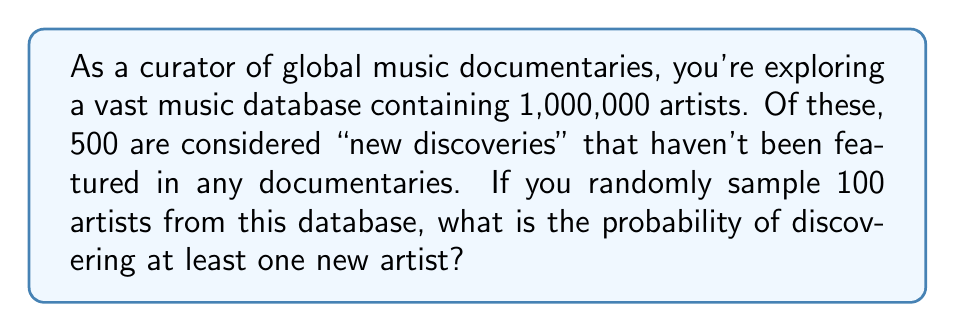Provide a solution to this math problem. Let's approach this step-by-step:

1) First, we need to calculate the probability of not selecting a new artist in a single draw:

   $P(\text{not new}) = \frac{1,000,000 - 500}{1,000,000} = 0.9995$

2) Now, for 100 independent draws, the probability of not selecting any new artist is:

   $P(\text{no new in 100 draws}) = (0.9995)^{100}$

3) Therefore, the probability of selecting at least one new artist is the complement of this:

   $P(\text{at least one new}) = 1 - (0.9995)^{100}$

4) Let's calculate this:

   $1 - (0.9995)^{100} = 1 - 0.9512 = 0.0488$

5) Converting to a percentage:

   $0.0488 \times 100\% = 4.88\%$

This result indicates that there's approximately a 4.88% chance of discovering at least one new artist when randomly sampling 100 artists from this database.
Answer: $4.88\%$ 